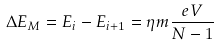<formula> <loc_0><loc_0><loc_500><loc_500>\Delta E _ { M } = E _ { i } - E _ { i + 1 } = \eta m \frac { e V } { N - 1 }</formula> 